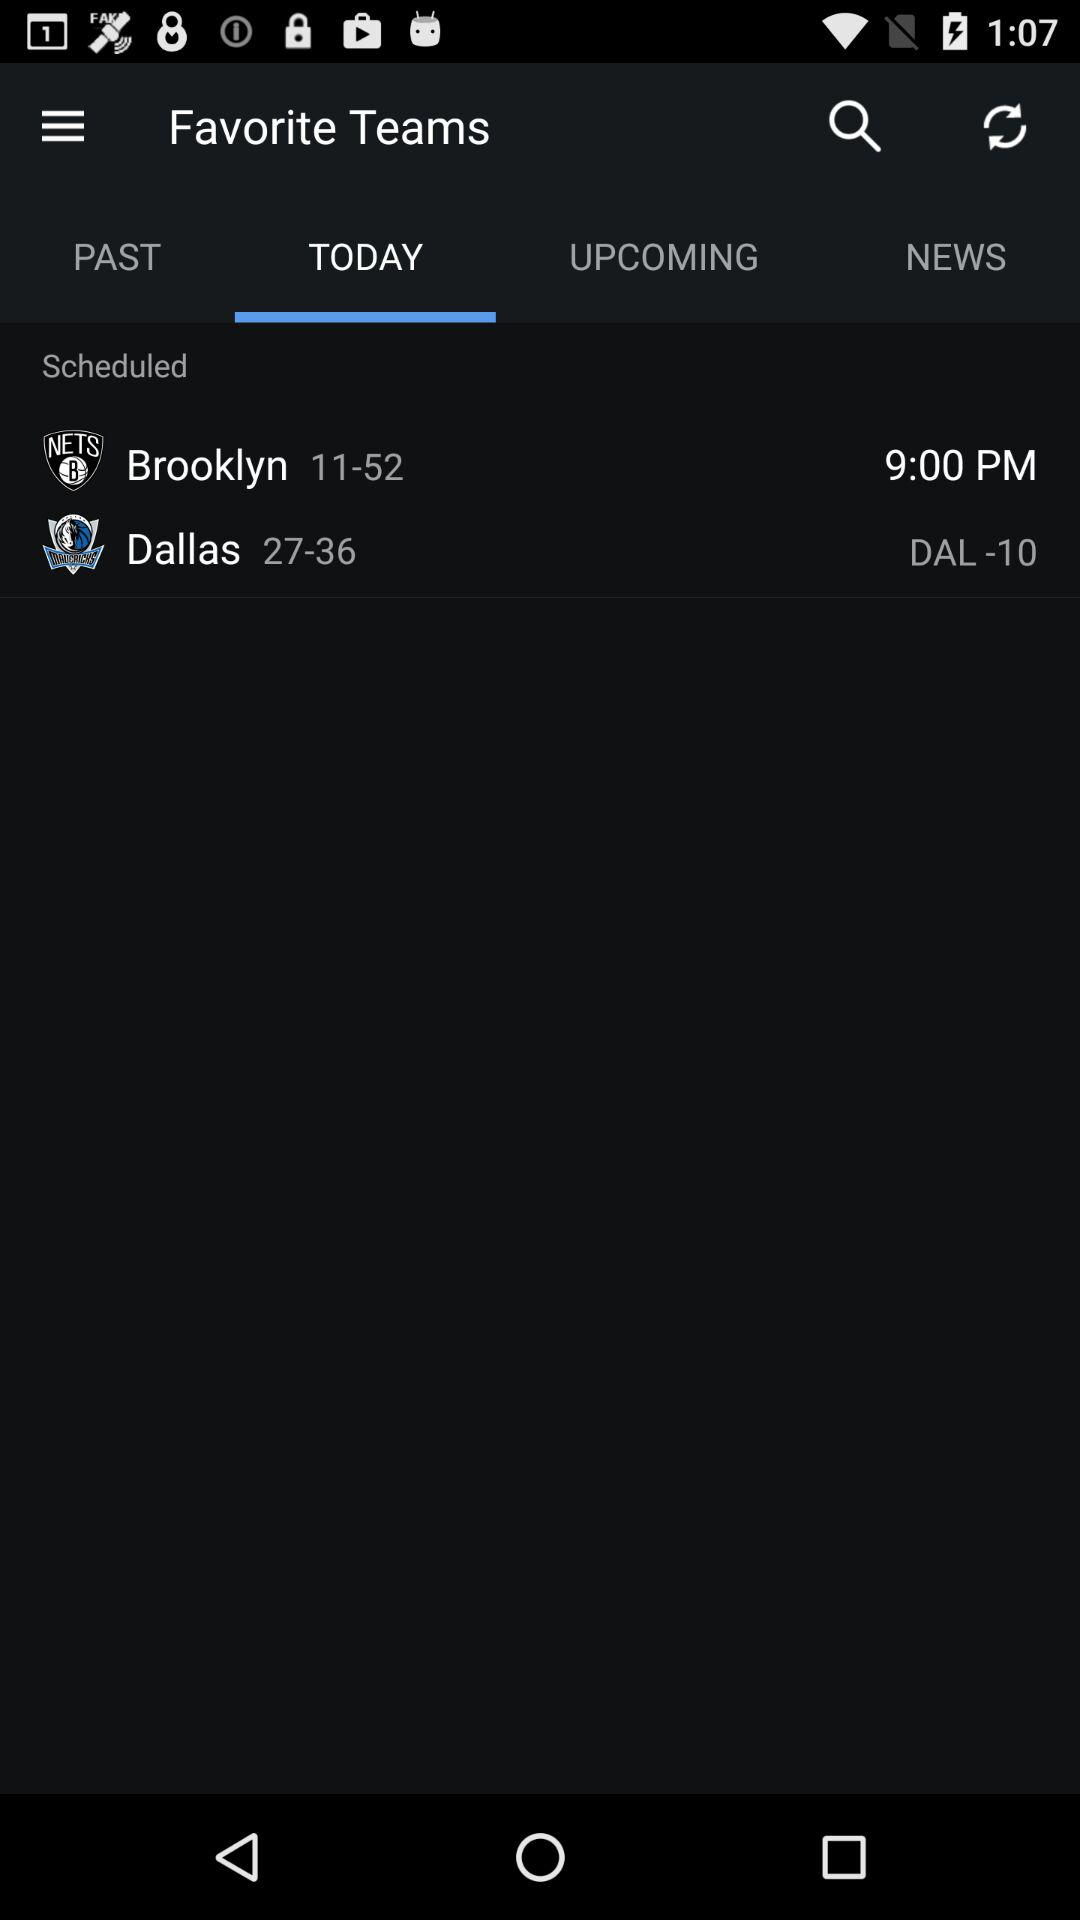What is the scheduled time for the "Brooklyn" team? The scheduled time is 9:00 PM. 